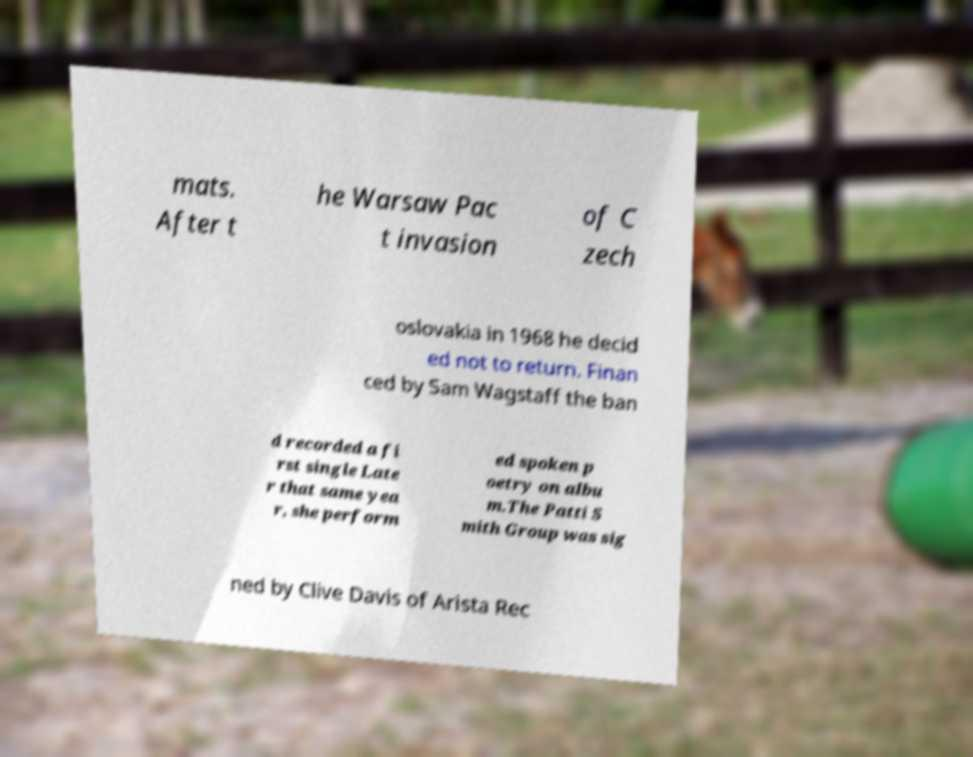Please identify and transcribe the text found in this image. mats. After t he Warsaw Pac t invasion of C zech oslovakia in 1968 he decid ed not to return. Finan ced by Sam Wagstaff the ban d recorded a fi rst single Late r that same yea r, she perform ed spoken p oetry on albu m.The Patti S mith Group was sig ned by Clive Davis of Arista Rec 